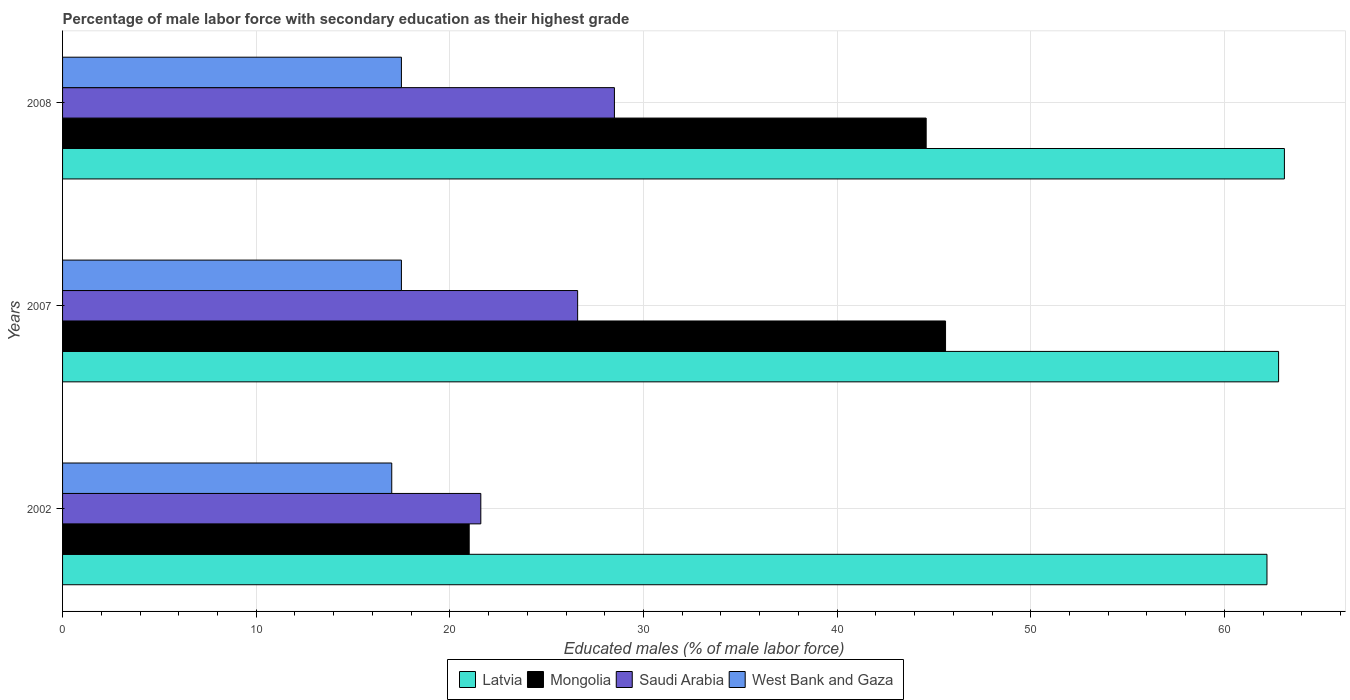How many bars are there on the 2nd tick from the top?
Offer a terse response. 4. How many bars are there on the 3rd tick from the bottom?
Give a very brief answer. 4. What is the percentage of male labor force with secondary education in West Bank and Gaza in 2007?
Offer a very short reply. 17.5. Across all years, what is the maximum percentage of male labor force with secondary education in Mongolia?
Your answer should be very brief. 45.6. Across all years, what is the minimum percentage of male labor force with secondary education in Saudi Arabia?
Give a very brief answer. 21.6. In which year was the percentage of male labor force with secondary education in Mongolia minimum?
Provide a succinct answer. 2002. What is the total percentage of male labor force with secondary education in Mongolia in the graph?
Your answer should be very brief. 111.2. What is the difference between the percentage of male labor force with secondary education in Latvia in 2002 and that in 2008?
Make the answer very short. -0.9. What is the difference between the percentage of male labor force with secondary education in Latvia in 2007 and the percentage of male labor force with secondary education in Saudi Arabia in 2002?
Provide a succinct answer. 41.2. What is the average percentage of male labor force with secondary education in Mongolia per year?
Offer a very short reply. 37.07. In the year 2002, what is the difference between the percentage of male labor force with secondary education in Mongolia and percentage of male labor force with secondary education in Latvia?
Your response must be concise. -41.2. What is the ratio of the percentage of male labor force with secondary education in Mongolia in 2002 to that in 2007?
Your answer should be very brief. 0.46. Is the percentage of male labor force with secondary education in West Bank and Gaza in 2007 less than that in 2008?
Provide a short and direct response. No. Is the difference between the percentage of male labor force with secondary education in Mongolia in 2007 and 2008 greater than the difference between the percentage of male labor force with secondary education in Latvia in 2007 and 2008?
Your response must be concise. Yes. What is the difference between the highest and the second highest percentage of male labor force with secondary education in Saudi Arabia?
Offer a terse response. 1.9. What is the difference between the highest and the lowest percentage of male labor force with secondary education in Mongolia?
Your response must be concise. 24.6. Is it the case that in every year, the sum of the percentage of male labor force with secondary education in Mongolia and percentage of male labor force with secondary education in West Bank and Gaza is greater than the sum of percentage of male labor force with secondary education in Saudi Arabia and percentage of male labor force with secondary education in Latvia?
Your answer should be compact. No. What does the 1st bar from the top in 2007 represents?
Make the answer very short. West Bank and Gaza. What does the 4th bar from the bottom in 2007 represents?
Keep it short and to the point. West Bank and Gaza. Is it the case that in every year, the sum of the percentage of male labor force with secondary education in West Bank and Gaza and percentage of male labor force with secondary education in Saudi Arabia is greater than the percentage of male labor force with secondary education in Mongolia?
Provide a succinct answer. No. How many years are there in the graph?
Your response must be concise. 3. Are the values on the major ticks of X-axis written in scientific E-notation?
Offer a terse response. No. Does the graph contain any zero values?
Your answer should be compact. No. What is the title of the graph?
Your answer should be very brief. Percentage of male labor force with secondary education as their highest grade. What is the label or title of the X-axis?
Your answer should be very brief. Educated males (% of male labor force). What is the Educated males (% of male labor force) of Latvia in 2002?
Your response must be concise. 62.2. What is the Educated males (% of male labor force) of Saudi Arabia in 2002?
Offer a very short reply. 21.6. What is the Educated males (% of male labor force) in Latvia in 2007?
Your answer should be very brief. 62.8. What is the Educated males (% of male labor force) in Mongolia in 2007?
Give a very brief answer. 45.6. What is the Educated males (% of male labor force) in Saudi Arabia in 2007?
Provide a short and direct response. 26.6. What is the Educated males (% of male labor force) in Latvia in 2008?
Give a very brief answer. 63.1. What is the Educated males (% of male labor force) in Mongolia in 2008?
Your response must be concise. 44.6. What is the Educated males (% of male labor force) in Saudi Arabia in 2008?
Make the answer very short. 28.5. What is the Educated males (% of male labor force) in West Bank and Gaza in 2008?
Provide a short and direct response. 17.5. Across all years, what is the maximum Educated males (% of male labor force) of Latvia?
Offer a terse response. 63.1. Across all years, what is the maximum Educated males (% of male labor force) of Mongolia?
Ensure brevity in your answer.  45.6. Across all years, what is the minimum Educated males (% of male labor force) in Latvia?
Offer a very short reply. 62.2. Across all years, what is the minimum Educated males (% of male labor force) of Saudi Arabia?
Provide a short and direct response. 21.6. What is the total Educated males (% of male labor force) of Latvia in the graph?
Keep it short and to the point. 188.1. What is the total Educated males (% of male labor force) in Mongolia in the graph?
Ensure brevity in your answer.  111.2. What is the total Educated males (% of male labor force) in Saudi Arabia in the graph?
Offer a terse response. 76.7. What is the difference between the Educated males (% of male labor force) of Latvia in 2002 and that in 2007?
Offer a terse response. -0.6. What is the difference between the Educated males (% of male labor force) in Mongolia in 2002 and that in 2007?
Keep it short and to the point. -24.6. What is the difference between the Educated males (% of male labor force) in West Bank and Gaza in 2002 and that in 2007?
Your answer should be compact. -0.5. What is the difference between the Educated males (% of male labor force) of Latvia in 2002 and that in 2008?
Offer a very short reply. -0.9. What is the difference between the Educated males (% of male labor force) in Mongolia in 2002 and that in 2008?
Give a very brief answer. -23.6. What is the difference between the Educated males (% of male labor force) of West Bank and Gaza in 2002 and that in 2008?
Offer a very short reply. -0.5. What is the difference between the Educated males (% of male labor force) of Latvia in 2007 and that in 2008?
Your response must be concise. -0.3. What is the difference between the Educated males (% of male labor force) of Latvia in 2002 and the Educated males (% of male labor force) of Saudi Arabia in 2007?
Make the answer very short. 35.6. What is the difference between the Educated males (% of male labor force) in Latvia in 2002 and the Educated males (% of male labor force) in West Bank and Gaza in 2007?
Your answer should be very brief. 44.7. What is the difference between the Educated males (% of male labor force) in Mongolia in 2002 and the Educated males (% of male labor force) in West Bank and Gaza in 2007?
Your response must be concise. 3.5. What is the difference between the Educated males (% of male labor force) of Saudi Arabia in 2002 and the Educated males (% of male labor force) of West Bank and Gaza in 2007?
Provide a succinct answer. 4.1. What is the difference between the Educated males (% of male labor force) in Latvia in 2002 and the Educated males (% of male labor force) in Mongolia in 2008?
Provide a succinct answer. 17.6. What is the difference between the Educated males (% of male labor force) in Latvia in 2002 and the Educated males (% of male labor force) in Saudi Arabia in 2008?
Offer a terse response. 33.7. What is the difference between the Educated males (% of male labor force) of Latvia in 2002 and the Educated males (% of male labor force) of West Bank and Gaza in 2008?
Offer a terse response. 44.7. What is the difference between the Educated males (% of male labor force) of Latvia in 2007 and the Educated males (% of male labor force) of Saudi Arabia in 2008?
Keep it short and to the point. 34.3. What is the difference between the Educated males (% of male labor force) of Latvia in 2007 and the Educated males (% of male labor force) of West Bank and Gaza in 2008?
Provide a short and direct response. 45.3. What is the difference between the Educated males (% of male labor force) in Mongolia in 2007 and the Educated males (% of male labor force) in West Bank and Gaza in 2008?
Your answer should be compact. 28.1. What is the difference between the Educated males (% of male labor force) of Saudi Arabia in 2007 and the Educated males (% of male labor force) of West Bank and Gaza in 2008?
Your response must be concise. 9.1. What is the average Educated males (% of male labor force) in Latvia per year?
Keep it short and to the point. 62.7. What is the average Educated males (% of male labor force) in Mongolia per year?
Provide a short and direct response. 37.07. What is the average Educated males (% of male labor force) in Saudi Arabia per year?
Give a very brief answer. 25.57. What is the average Educated males (% of male labor force) in West Bank and Gaza per year?
Your answer should be compact. 17.33. In the year 2002, what is the difference between the Educated males (% of male labor force) of Latvia and Educated males (% of male labor force) of Mongolia?
Your answer should be compact. 41.2. In the year 2002, what is the difference between the Educated males (% of male labor force) in Latvia and Educated males (% of male labor force) in Saudi Arabia?
Ensure brevity in your answer.  40.6. In the year 2002, what is the difference between the Educated males (% of male labor force) of Latvia and Educated males (% of male labor force) of West Bank and Gaza?
Provide a succinct answer. 45.2. In the year 2002, what is the difference between the Educated males (% of male labor force) in Mongolia and Educated males (% of male labor force) in Saudi Arabia?
Provide a short and direct response. -0.6. In the year 2002, what is the difference between the Educated males (% of male labor force) in Mongolia and Educated males (% of male labor force) in West Bank and Gaza?
Offer a terse response. 4. In the year 2007, what is the difference between the Educated males (% of male labor force) of Latvia and Educated males (% of male labor force) of Saudi Arabia?
Give a very brief answer. 36.2. In the year 2007, what is the difference between the Educated males (% of male labor force) in Latvia and Educated males (% of male labor force) in West Bank and Gaza?
Your answer should be compact. 45.3. In the year 2007, what is the difference between the Educated males (% of male labor force) in Mongolia and Educated males (% of male labor force) in West Bank and Gaza?
Your answer should be compact. 28.1. In the year 2007, what is the difference between the Educated males (% of male labor force) in Saudi Arabia and Educated males (% of male labor force) in West Bank and Gaza?
Provide a succinct answer. 9.1. In the year 2008, what is the difference between the Educated males (% of male labor force) in Latvia and Educated males (% of male labor force) in Saudi Arabia?
Provide a succinct answer. 34.6. In the year 2008, what is the difference between the Educated males (% of male labor force) of Latvia and Educated males (% of male labor force) of West Bank and Gaza?
Your answer should be very brief. 45.6. In the year 2008, what is the difference between the Educated males (% of male labor force) in Mongolia and Educated males (% of male labor force) in Saudi Arabia?
Keep it short and to the point. 16.1. In the year 2008, what is the difference between the Educated males (% of male labor force) of Mongolia and Educated males (% of male labor force) of West Bank and Gaza?
Give a very brief answer. 27.1. In the year 2008, what is the difference between the Educated males (% of male labor force) of Saudi Arabia and Educated males (% of male labor force) of West Bank and Gaza?
Your answer should be compact. 11. What is the ratio of the Educated males (% of male labor force) in Latvia in 2002 to that in 2007?
Offer a terse response. 0.99. What is the ratio of the Educated males (% of male labor force) in Mongolia in 2002 to that in 2007?
Give a very brief answer. 0.46. What is the ratio of the Educated males (% of male labor force) of Saudi Arabia in 2002 to that in 2007?
Ensure brevity in your answer.  0.81. What is the ratio of the Educated males (% of male labor force) of West Bank and Gaza in 2002 to that in 2007?
Give a very brief answer. 0.97. What is the ratio of the Educated males (% of male labor force) in Latvia in 2002 to that in 2008?
Provide a short and direct response. 0.99. What is the ratio of the Educated males (% of male labor force) in Mongolia in 2002 to that in 2008?
Make the answer very short. 0.47. What is the ratio of the Educated males (% of male labor force) in Saudi Arabia in 2002 to that in 2008?
Offer a very short reply. 0.76. What is the ratio of the Educated males (% of male labor force) in West Bank and Gaza in 2002 to that in 2008?
Offer a terse response. 0.97. What is the ratio of the Educated males (% of male labor force) of Latvia in 2007 to that in 2008?
Ensure brevity in your answer.  1. What is the ratio of the Educated males (% of male labor force) of Mongolia in 2007 to that in 2008?
Give a very brief answer. 1.02. What is the ratio of the Educated males (% of male labor force) of Saudi Arabia in 2007 to that in 2008?
Provide a succinct answer. 0.93. What is the difference between the highest and the second highest Educated males (% of male labor force) in Saudi Arabia?
Give a very brief answer. 1.9. What is the difference between the highest and the second highest Educated males (% of male labor force) in West Bank and Gaza?
Provide a succinct answer. 0. What is the difference between the highest and the lowest Educated males (% of male labor force) of Mongolia?
Provide a succinct answer. 24.6. What is the difference between the highest and the lowest Educated males (% of male labor force) of Saudi Arabia?
Your response must be concise. 6.9. What is the difference between the highest and the lowest Educated males (% of male labor force) in West Bank and Gaza?
Your answer should be very brief. 0.5. 